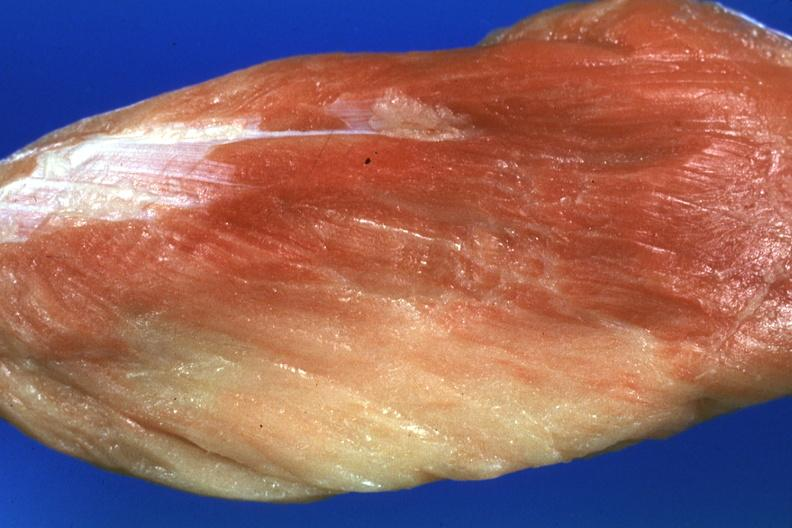does saggital section typical show close-up with some red muscle remaining?
Answer the question using a single word or phrase. No 